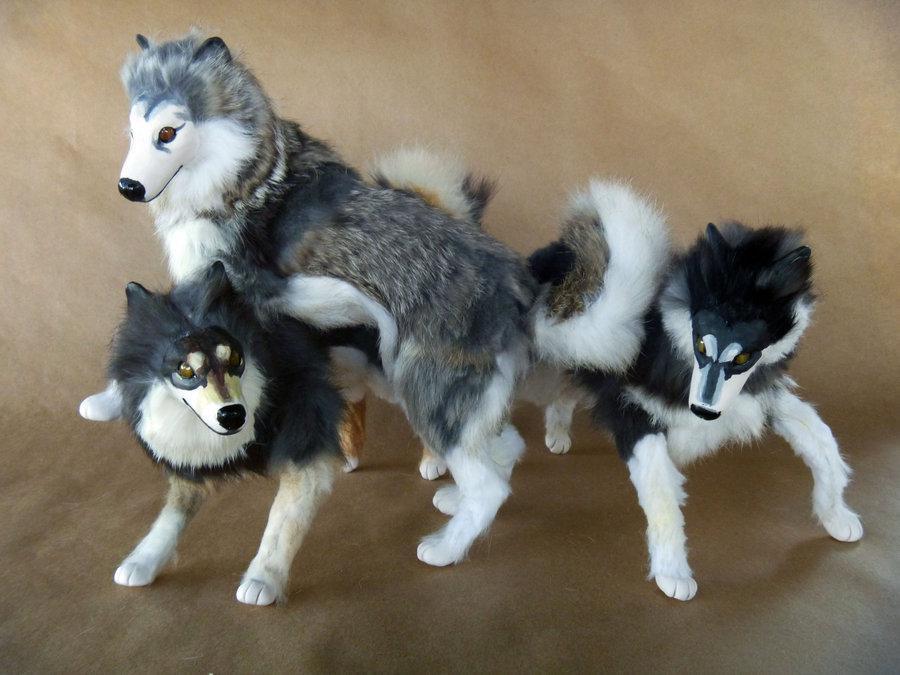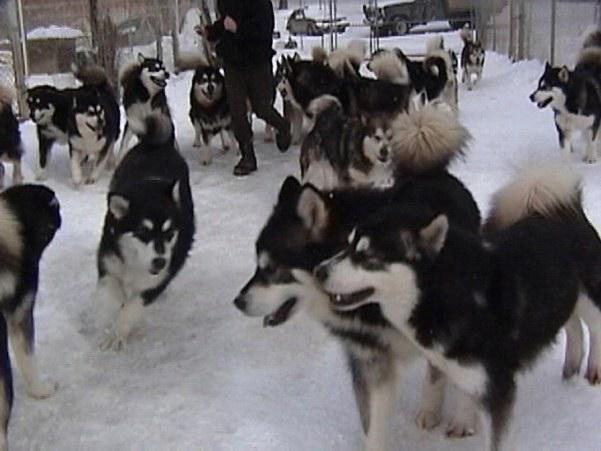The first image is the image on the left, the second image is the image on the right. Assess this claim about the two images: "The left image contains exactly two dogs.". Correct or not? Answer yes or no. No. The first image is the image on the left, the second image is the image on the right. Evaluate the accuracy of this statement regarding the images: "Each image contains two husky dogs positioned close together, and one image features dogs standing on snow-covered ground.". Is it true? Answer yes or no. No. 